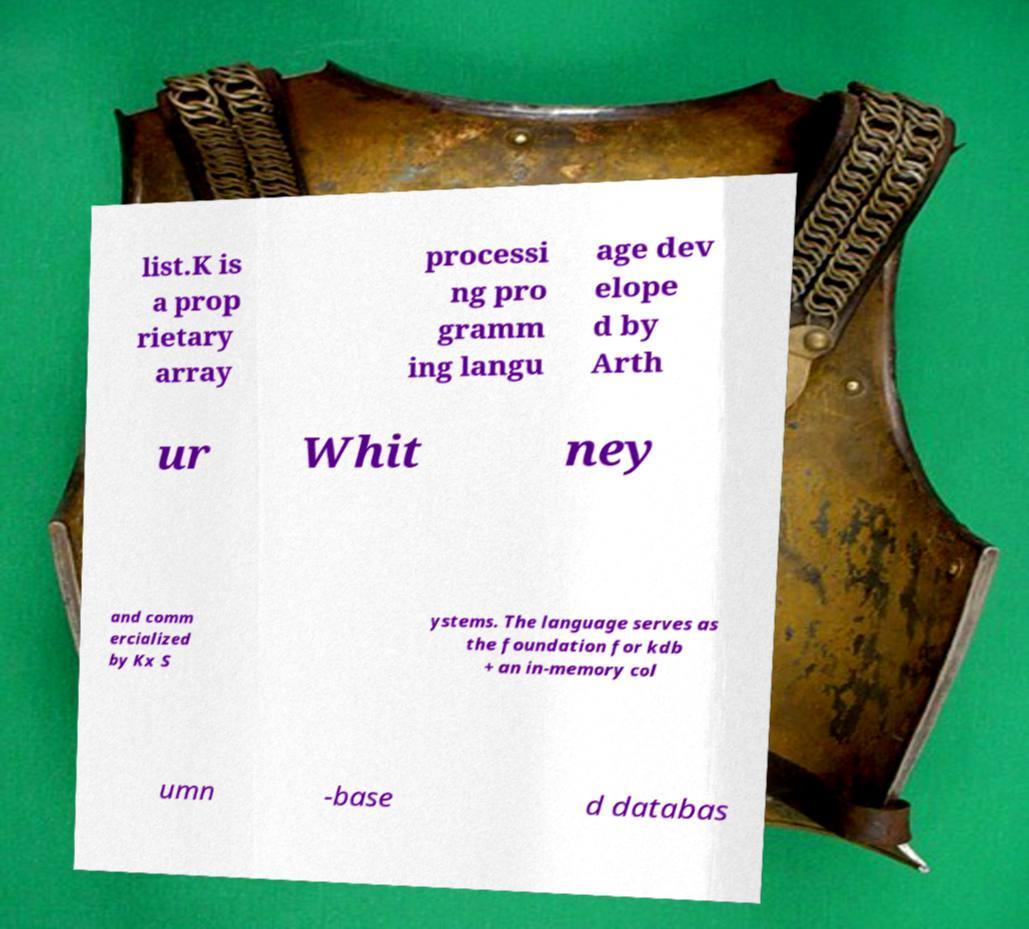Can you read and provide the text displayed in the image?This photo seems to have some interesting text. Can you extract and type it out for me? list.K is a prop rietary array processi ng pro gramm ing langu age dev elope d by Arth ur Whit ney and comm ercialized by Kx S ystems. The language serves as the foundation for kdb + an in-memory col umn -base d databas 